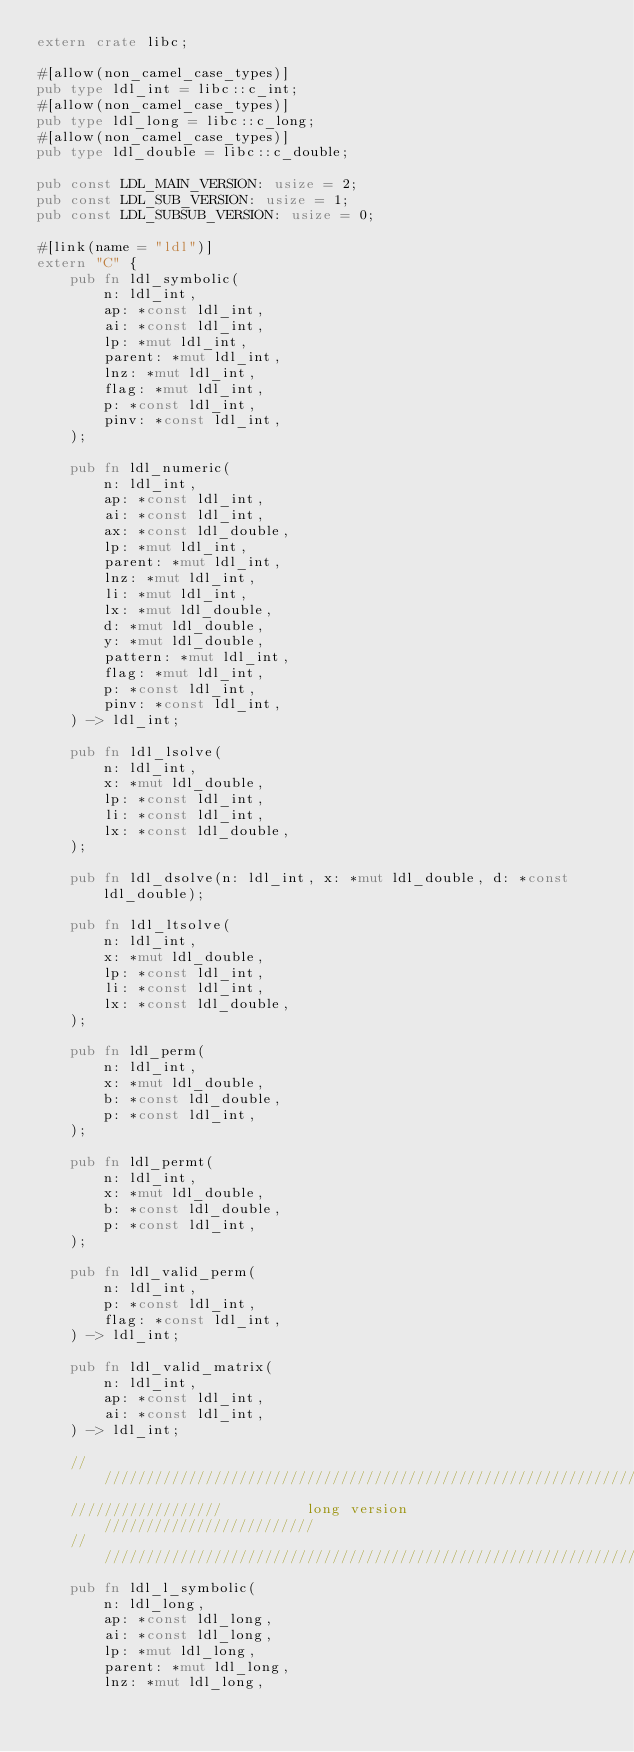<code> <loc_0><loc_0><loc_500><loc_500><_Rust_>extern crate libc;

#[allow(non_camel_case_types)]
pub type ldl_int = libc::c_int;
#[allow(non_camel_case_types)]
pub type ldl_long = libc::c_long;
#[allow(non_camel_case_types)]
pub type ldl_double = libc::c_double;

pub const LDL_MAIN_VERSION: usize = 2;
pub const LDL_SUB_VERSION: usize = 1;
pub const LDL_SUBSUB_VERSION: usize = 0;

#[link(name = "ldl")]
extern "C" {
    pub fn ldl_symbolic(
        n: ldl_int,
        ap: *const ldl_int,
        ai: *const ldl_int,
        lp: *mut ldl_int,
        parent: *mut ldl_int,
        lnz: *mut ldl_int,
        flag: *mut ldl_int,
        p: *const ldl_int,
        pinv: *const ldl_int,
    );

    pub fn ldl_numeric(
        n: ldl_int,
        ap: *const ldl_int,
        ai: *const ldl_int,
        ax: *const ldl_double,
        lp: *mut ldl_int,
        parent: *mut ldl_int,
        lnz: *mut ldl_int,
        li: *mut ldl_int,
        lx: *mut ldl_double,
        d: *mut ldl_double,
        y: *mut ldl_double,
        pattern: *mut ldl_int,
        flag: *mut ldl_int,
        p: *const ldl_int,
        pinv: *const ldl_int,
    ) -> ldl_int;

    pub fn ldl_lsolve(
        n: ldl_int,
        x: *mut ldl_double,
        lp: *const ldl_int,
        li: *const ldl_int,
        lx: *const ldl_double,
    );

    pub fn ldl_dsolve(n: ldl_int, x: *mut ldl_double, d: *const ldl_double);

    pub fn ldl_ltsolve(
        n: ldl_int,
        x: *mut ldl_double,
        lp: *const ldl_int,
        li: *const ldl_int,
        lx: *const ldl_double,
    );

    pub fn ldl_perm(
        n: ldl_int,
        x: *mut ldl_double,
        b: *const ldl_double,
        p: *const ldl_int,
    );

    pub fn ldl_permt(
        n: ldl_int,
        x: *mut ldl_double,
        b: *const ldl_double,
        p: *const ldl_int,
    );

    pub fn ldl_valid_perm(
        n: ldl_int,
        p: *const ldl_int,
        flag: *const ldl_int,
    ) -> ldl_int;

    pub fn ldl_valid_matrix(
        n: ldl_int,
        ap: *const ldl_int,
        ai: *const ldl_int,
    ) -> ldl_int;

    ////////////////////////////////////////////////////////////////////////////
    //////////////////          long version           /////////////////////////
    ////////////////////////////////////////////////////////////////////////////
    pub fn ldl_l_symbolic(
        n: ldl_long,
        ap: *const ldl_long,
        ai: *const ldl_long,
        lp: *mut ldl_long,
        parent: *mut ldl_long,
        lnz: *mut ldl_long,</code> 